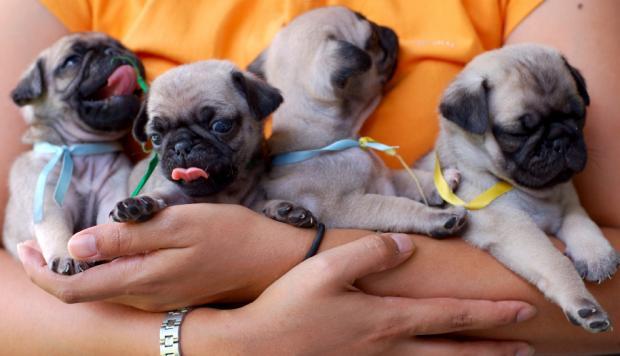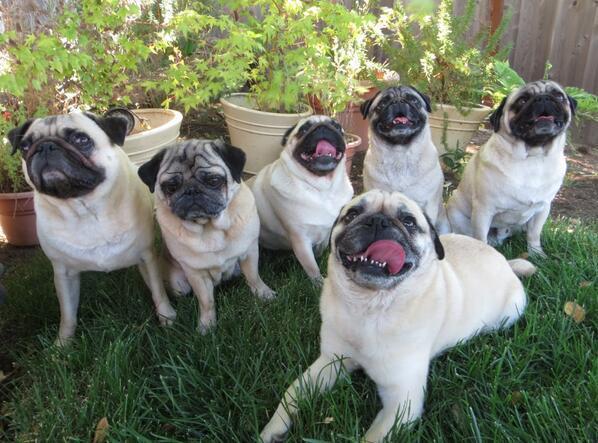The first image is the image on the left, the second image is the image on the right. Examine the images to the left and right. Is the description "One of the paired images shows exactly four pug puppies." accurate? Answer yes or no. Yes. 